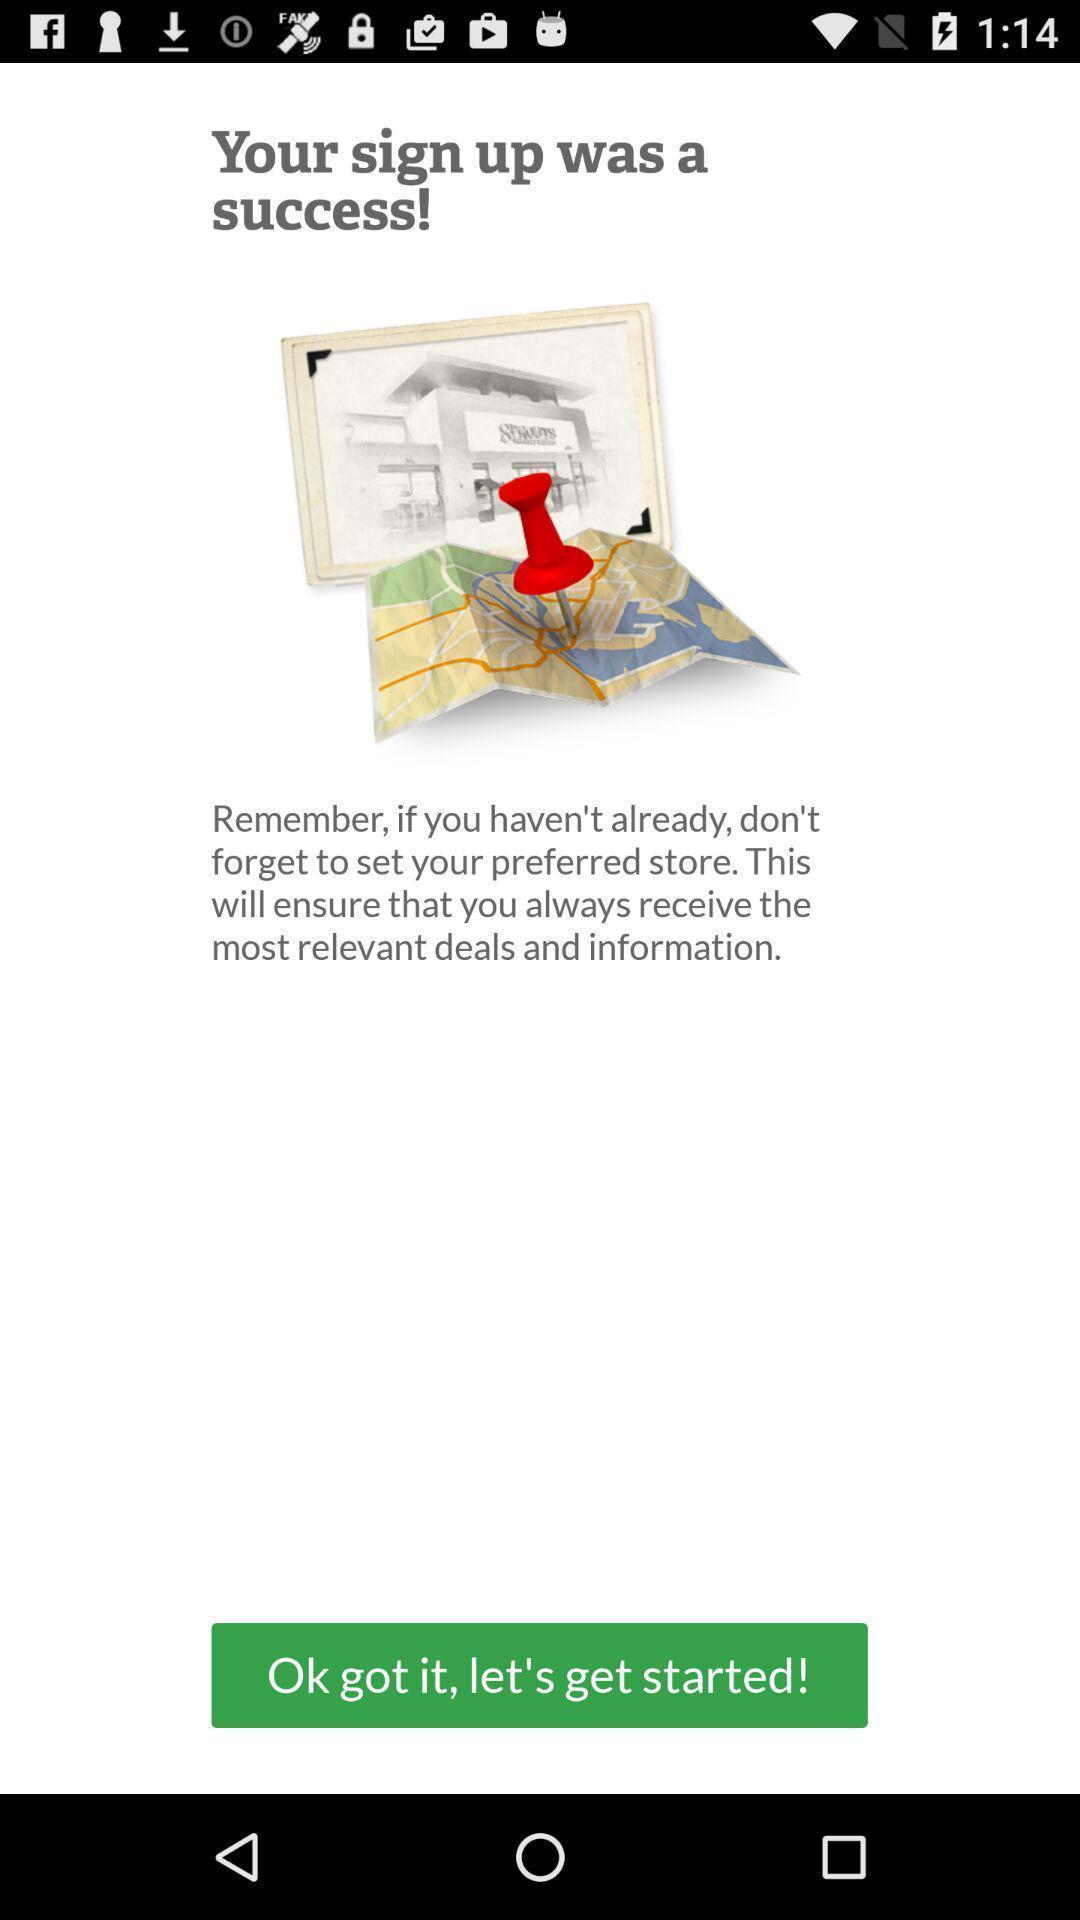Give me a narrative description of this picture. Welcome page for a mapping app. 